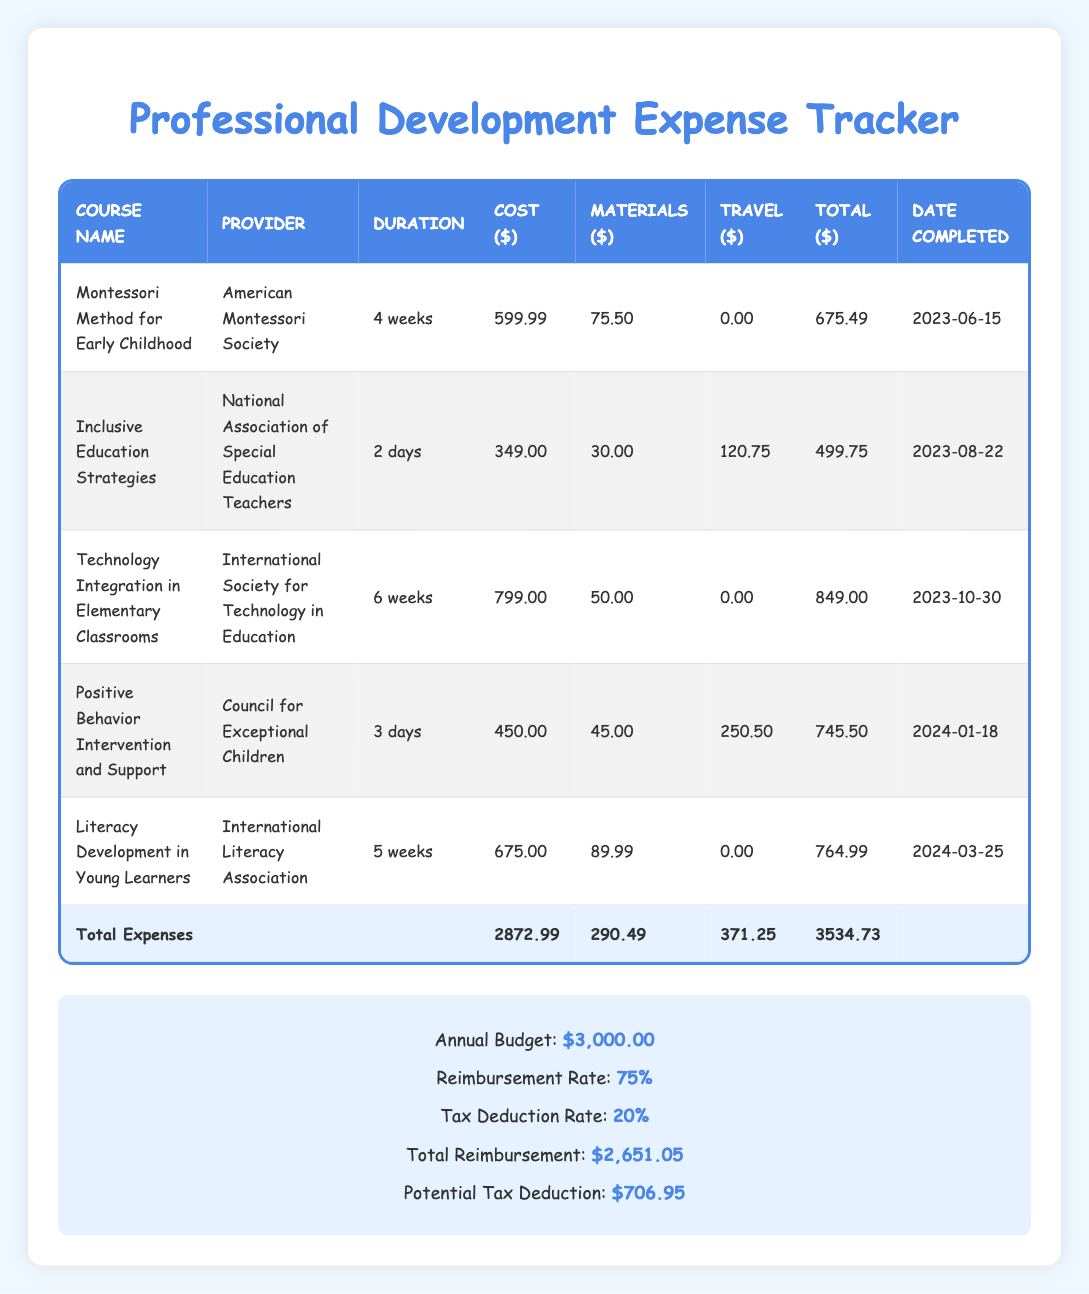What is the total cost of the "Montessori Method for Early Childhood" course? The total cost for the course includes both the cost and materials expenses. The cost is 599.99 and materials is 75.50, so we add them: 599.99 + 75.50 = 675.49.
Answer: 675.49 What is the duration of the "Technology Integration in Elementary Classrooms" course? The duration for this course is listed directly in the table under the duration column. It states "6 weeks."
Answer: 6 weeks Did the "Inclusive Education Strategies" course have any travel expenses? The travel expenses for this course are noted in the table, and they are listed as 120.75, indicating there were travel expenses incurred.
Answer: Yes What is the total reimbursement amount based on the reimbursement rate provided? The total expenses amount is 2872.99. The reimbursement rate is 75%, so we multiply 2872.99 by 0.75. That gives us 2154.74.
Answer: 2154.74 Which course had the highest total expenses? To find this, we compare the total expenses for each course. The highest total expenses are for "Technology Integration in Elementary Classrooms," which is 849.00.
Answer: Technology Integration in Elementary Classrooms What is the total amount spent on materials across all courses? To find this, we sum the materials costs: 75.50 + 30.00 + 50.00 + 45.00 + 89.99 = 290.49.
Answer: 290.49 How much money is left from the annual budget after accounting for total expenses? We start with the annual budget of 3000.00 and subtract the total expenses of 2872.99: 3000.00 - 2872.99 = 127.01.
Answer: 127.01 Is the total expenses greater than the annual budget? The total expenses amount to 2872.99, which is less than the annual budget of 3000.00.
Answer: No What is the average cost of the courses that have travel expenses? The courses with travel expenses are "Inclusive Education Strategies," "Positive Behavior Intervention and Support." Their total costs are 499.75 and 745.50 respectively. The average is (499.75 + 745.50)/2 = 622.63.
Answer: 622.63 